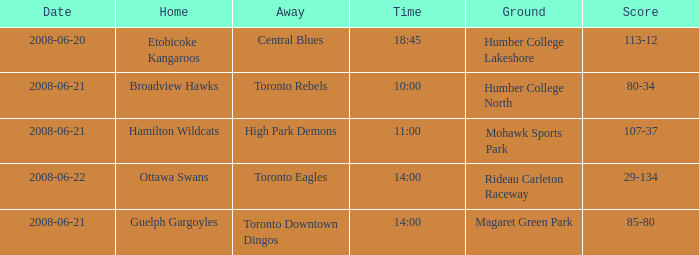What is the Ground with a Date that is 2008-06-20? Humber College Lakeshore. 